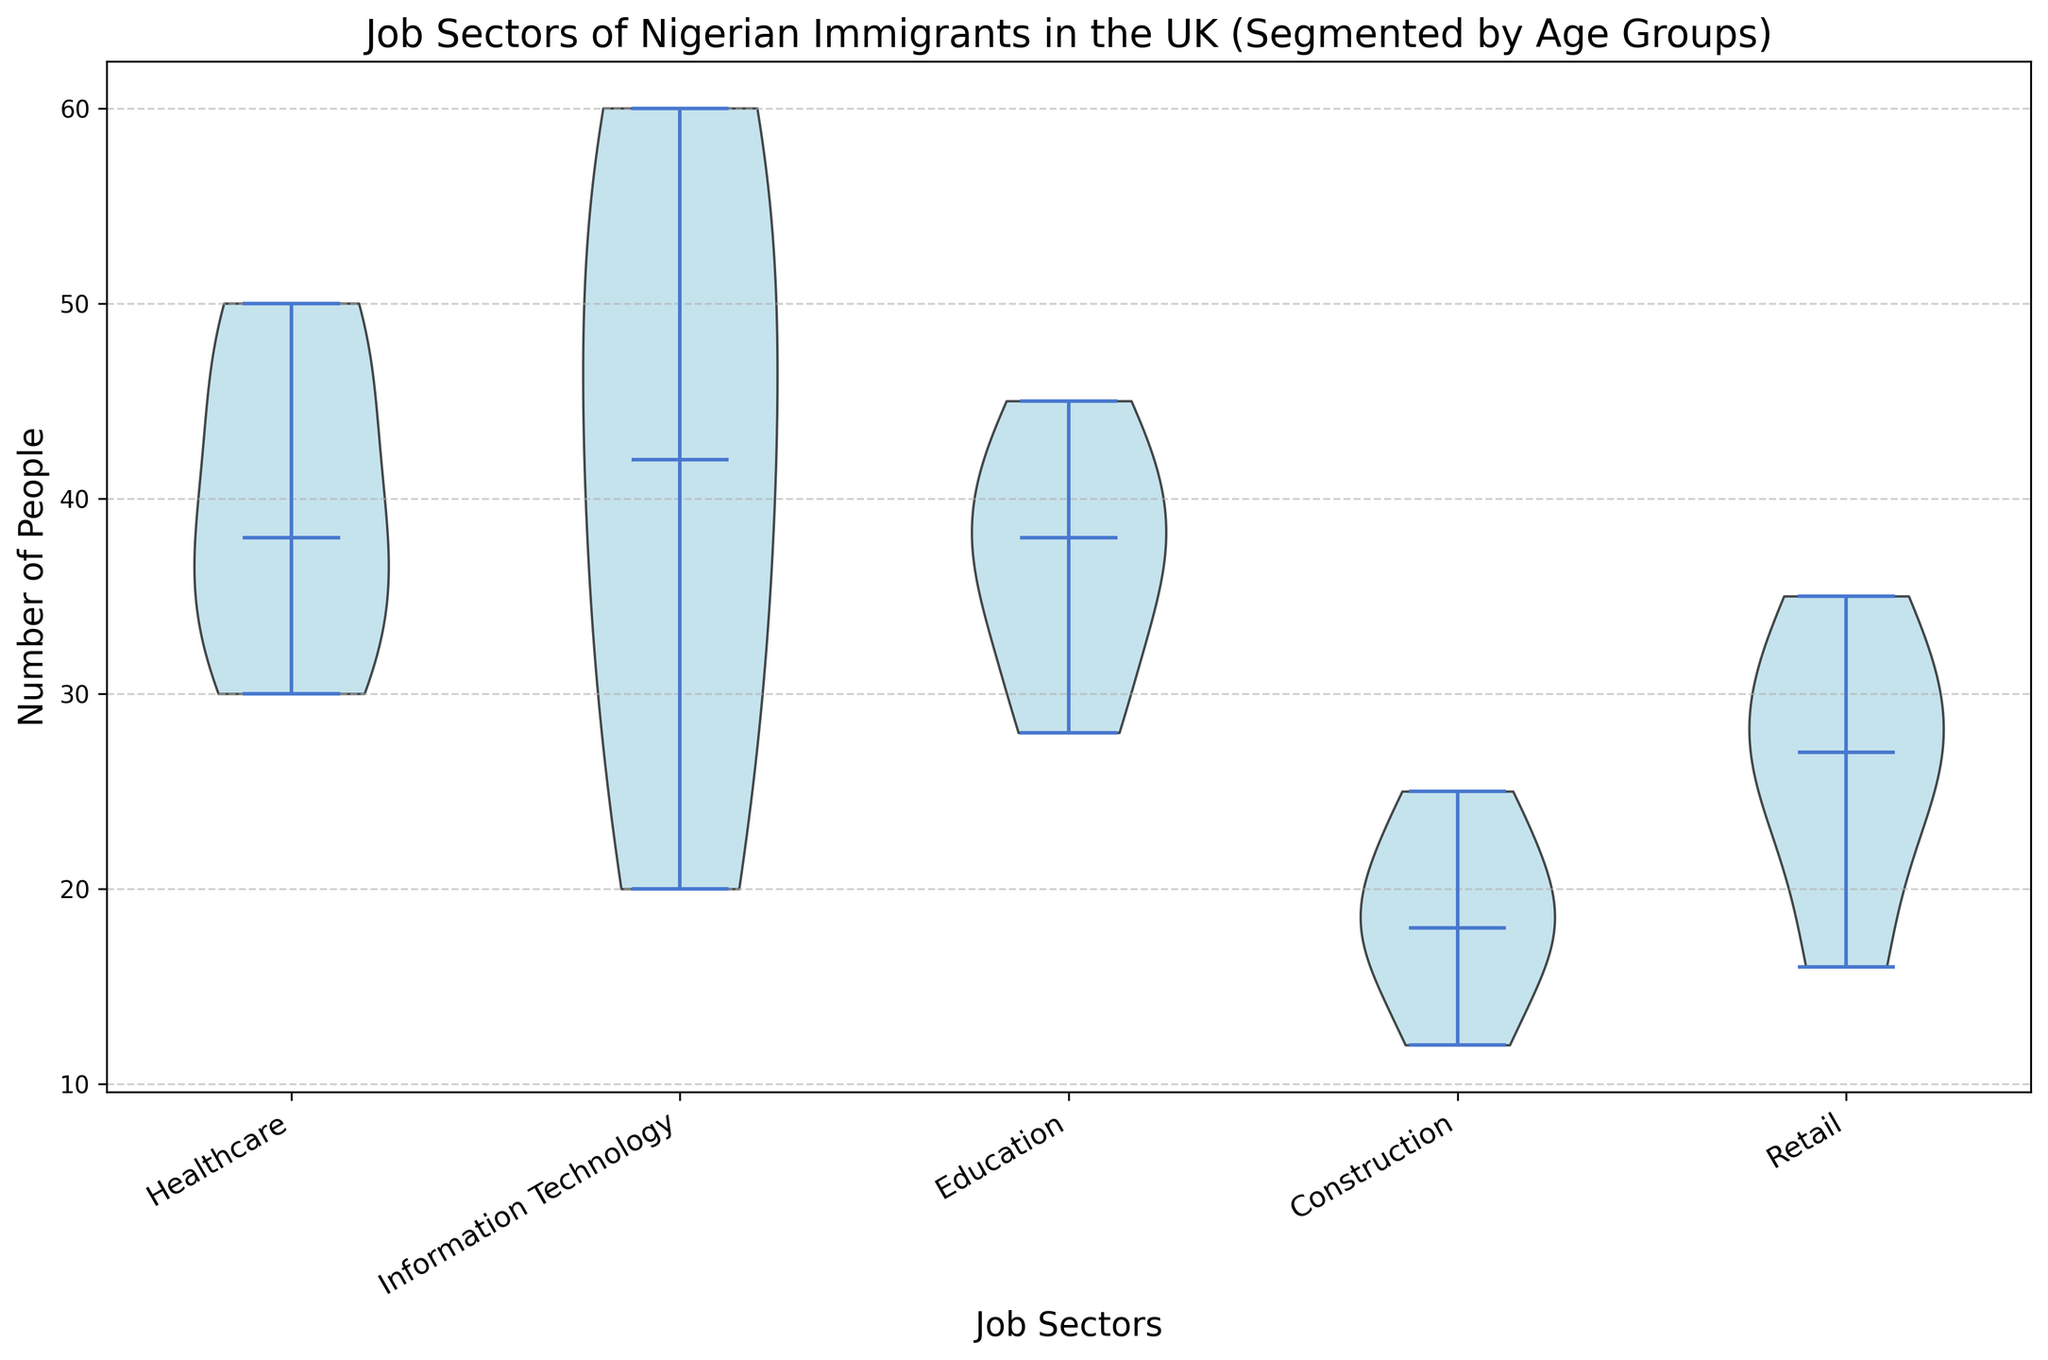How are job sectors distributed among the age group 18-25? Look at the heights of the violin plots for the age group 18-25 across different job sectors. Higher density around certain counts indicates the distribution of people in that age group.
Answer: Higher in Information Technology and Healthcare, lower in Construction Which job sector has the highest median count in the age group 36-45? Look at the median indicators (usually a line or a point in the center of the violin plot) for the age group 36-45 across different job sectors.
Answer: Information Technology In which age group does Healthcare have the highest number of people? Observe the height and density within the violin plot corresponding to Healthcare across different age groups. Identify the age group where the distribution peaks the highest.
Answer: 36-45 Compare the density distribution for Retail in the 46-55 and 56-65 age groups. Which has a higher median count? Look at the median lines within the violin plots for Retail for the age groups 46-55 and 56-65. The higher median line indicates the higher median count.
Answer: 46-55 Is the distribution of people in Information Technology more spread out in the age group 18-25 or 56-65? Look at the width of the violin plots for Information Technology in both age groups. The wider the plot, the more spread out the distribution.
Answer: 18-25 Which job sector has the most balanced distribution across all age groups? Observe the symmetry and height density of each violin plot across all age groups for every job sector. The most balanced one will show consistent heights and symmetrical distributions.
Answer: Education Is there a job sector where the number of people decreases consistently with age? Examine the trends in the height of the distributions across age groups for each job sector. Look for a downward trend in the density as age increases.
Answer: Information Technology Compare the spread of Construction jobs between the 18-25 and 36-45 age groups. Which age group has a higher spread? Look at the overall width of the violin plots for Construction in the age groups 18-25 and 36-45. The wider plot indicates a higher spread.
Answer: 18-25 Which age group has the highest median count in the Education sector? Observe the median lines within the violin plots for the Education sector across different age groups. Identify the age group with the highest median line.
Answer: 46-55 